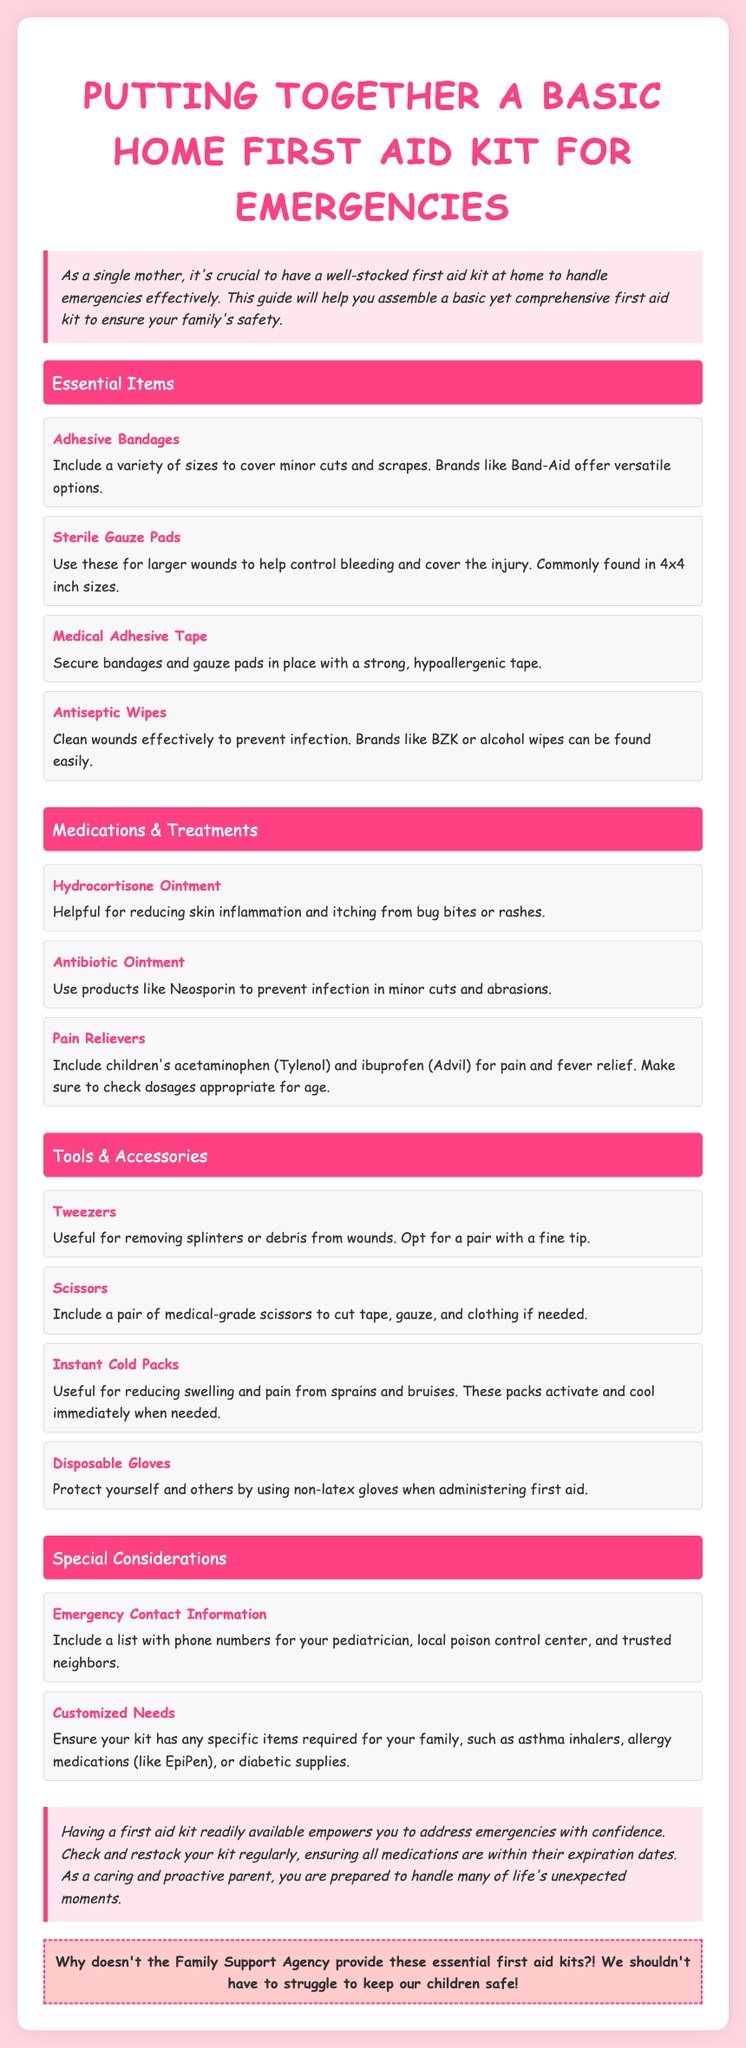what should be included in a first aid kit? The document lists essential items like Adhesive Bandages, Sterile Gauze Pads, and Antiseptic Wipes, among others.
Answer: Adhesive Bandages, Sterile Gauze Pads, Antiseptic Wipes how many essential items are mentioned? The document contains sections with 4 essential items, 3 medications, 4 tools, and 2 special considerations, totaling 13 items.
Answer: 13 who is the intended audience for this guide? The guide specifically mentions single mothers as the intended audience, highlighting the importance of having a first aid kit.
Answer: single mothers what is the purpose of antiseptic wipes? Antiseptic wipes are described as cleaning wounds effectively to prevent infection.
Answer: prevent infection what type of gloves should be used in first aid? The document specifies using non-latex gloves when administering first aid.
Answer: non-latex gloves what should be included in emergency contact information? The document advises including phone numbers for your pediatrician, local poison control center, and trusted neighbors.
Answer: pediatrician, poison control center, trusted neighbors how often should the first aid kit be checked? The document suggests checking and restocking the kit regularly.
Answer: regularly what is highlighted in the angry note? The angry note expresses frustration that the Family Support Agency does not provide essential first aid kits.
Answer: Family Support Agency does not provide essential first aid kits 